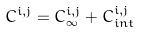<formula> <loc_0><loc_0><loc_500><loc_500>C ^ { i , j } = C _ { \infty } ^ { i , j } + C _ { i n t } ^ { i , j }</formula> 